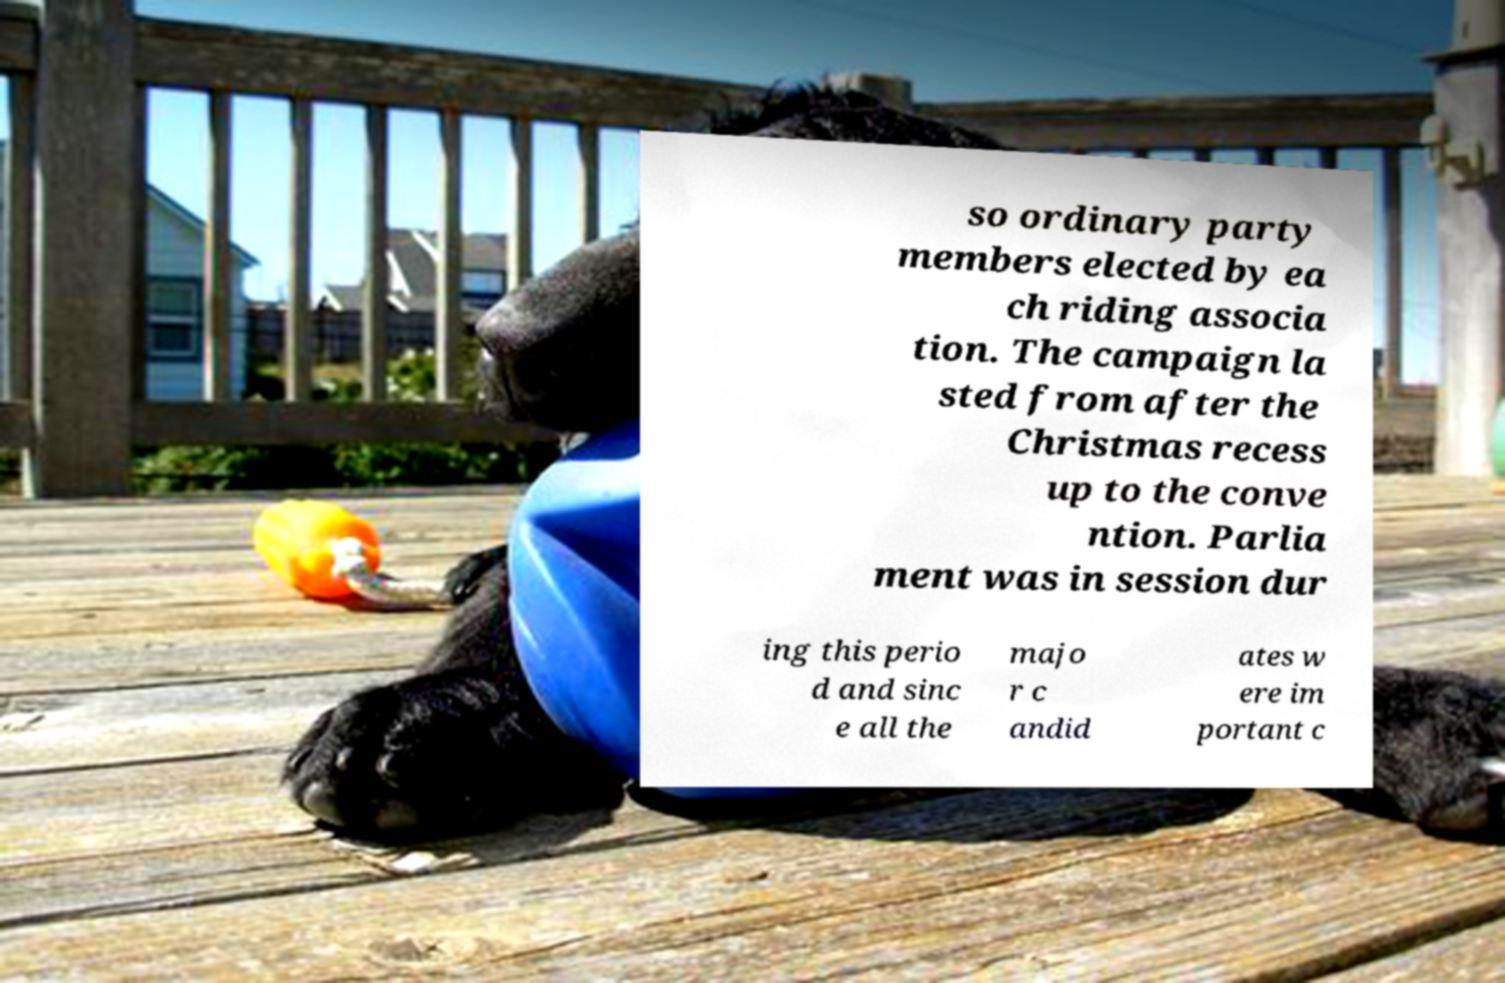Can you read and provide the text displayed in the image?This photo seems to have some interesting text. Can you extract and type it out for me? so ordinary party members elected by ea ch riding associa tion. The campaign la sted from after the Christmas recess up to the conve ntion. Parlia ment was in session dur ing this perio d and sinc e all the majo r c andid ates w ere im portant c 